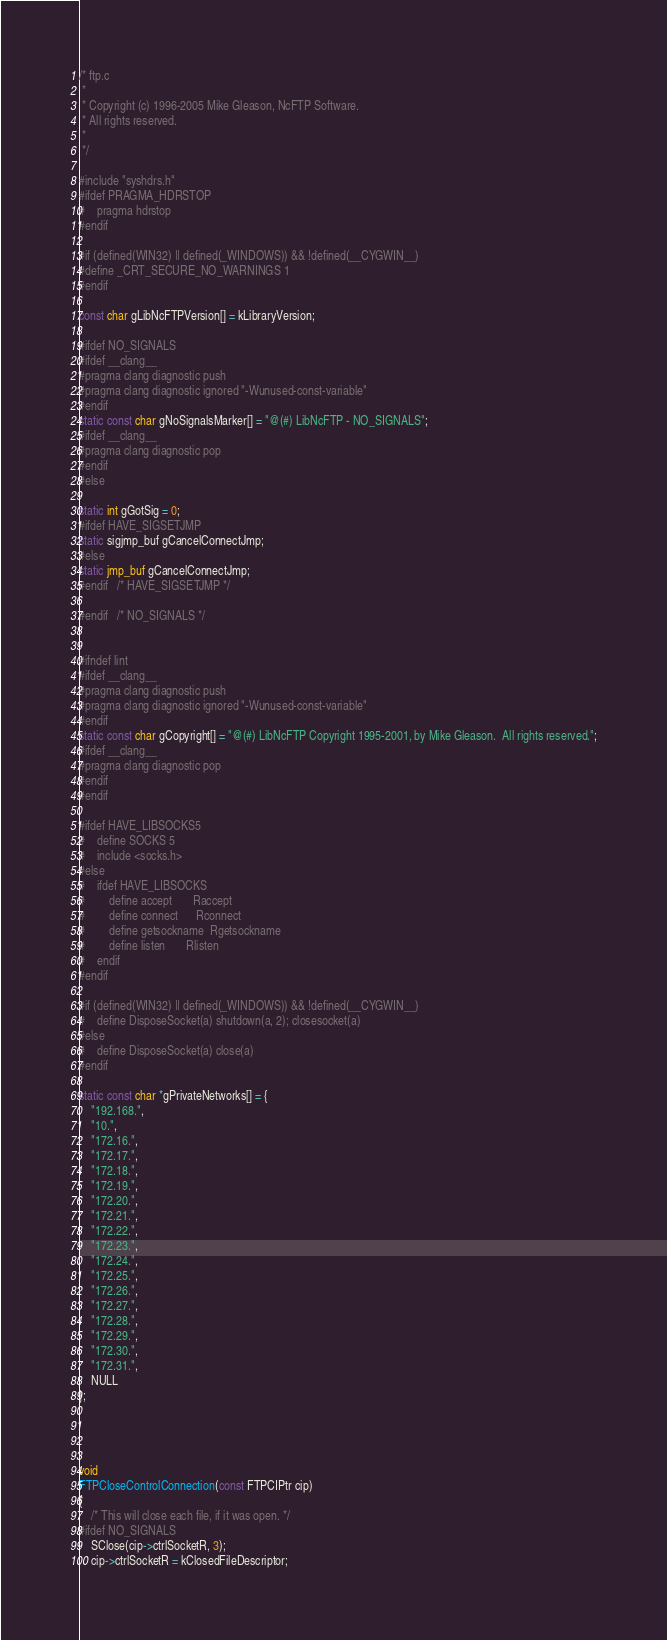<code> <loc_0><loc_0><loc_500><loc_500><_C_>/* ftp.c
 *
 * Copyright (c) 1996-2005 Mike Gleason, NcFTP Software.
 * All rights reserved.
 *
 */

#include "syshdrs.h"
#ifdef PRAGMA_HDRSTOP
#	pragma hdrstop
#endif

#if (defined(WIN32) || defined(_WINDOWS)) && !defined(__CYGWIN__)
#define _CRT_SECURE_NO_WARNINGS 1
#endif

const char gLibNcFTPVersion[] = kLibraryVersion;

#ifdef NO_SIGNALS
#ifdef __clang__
#pragma clang diagnostic push
#pragma clang diagnostic ignored "-Wunused-const-variable"
#endif
static const char gNoSignalsMarker[] = "@(#) LibNcFTP - NO_SIGNALS";
#ifdef __clang__
#pragma clang diagnostic pop
#endif
#else

static int gGotSig = 0;
#ifdef HAVE_SIGSETJMP
static sigjmp_buf gCancelConnectJmp;
#else
static jmp_buf gCancelConnectJmp;
#endif	/* HAVE_SIGSETJMP */

#endif	/* NO_SIGNALS */


#ifndef lint
#ifdef __clang__
#pragma clang diagnostic push
#pragma clang diagnostic ignored "-Wunused-const-variable"
#endif
static const char gCopyright[] = "@(#) LibNcFTP Copyright 1995-2001, by Mike Gleason.  All rights reserved.";
#ifdef __clang__
#pragma clang diagnostic pop
#endif
#endif

#ifdef HAVE_LIBSOCKS5
#	define SOCKS 5
#	include <socks.h>
#else
#	ifdef HAVE_LIBSOCKS
#		define accept		Raccept
#		define connect		Rconnect
#		define getsockname	Rgetsockname
#		define listen		Rlisten
#	endif
#endif

#if (defined(WIN32) || defined(_WINDOWS)) && !defined(__CYGWIN__)
#	define DisposeSocket(a) shutdown(a, 2); closesocket(a)
#else
#	define DisposeSocket(a) close(a)
#endif

static const char *gPrivateNetworks[] = {
	"192.168.",
	"10.",
	"172.16.",
	"172.17.",
	"172.18.",
	"172.19.",
	"172.20.",
	"172.21.",
	"172.22.",
	"172.23.",
	"172.24.",
	"172.25.",
	"172.26.",
	"172.27.",
	"172.28.",
	"172.29.",
	"172.30.",
	"172.31.",
	NULL
};




void
FTPCloseControlConnection(const FTPCIPtr cip)
{
	/* This will close each file, if it was open. */
#ifdef NO_SIGNALS
	SClose(cip->ctrlSocketR, 3);
	cip->ctrlSocketR = kClosedFileDescriptor;</code> 